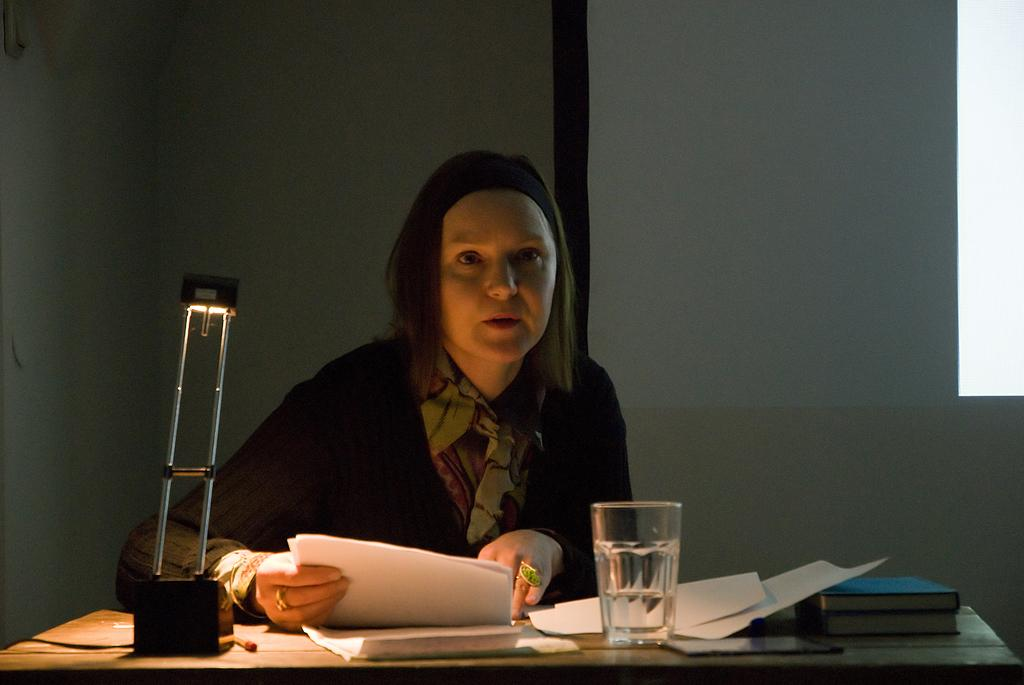What is the person in the image doing? The person is sitting on a chair and holding a paper. What is on the table in the image? There is a glass, papers, books, and a mobile phone on the table. Can you describe the person's interaction with the table? The person is holding a paper, which might suggest they are working or reading. What object on the table might be used for communication? The mobile phone on the table might be used for communication. What is the cause of the person's sudden laughter in the image? There is no indication of laughter in the image, so we cannot determine the cause. 